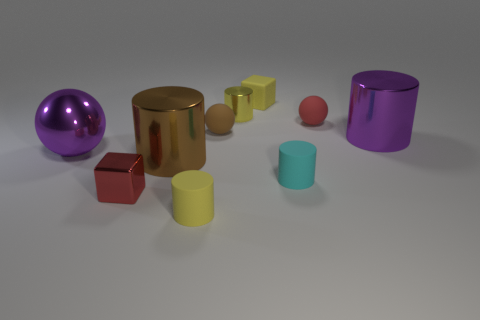What is the size of the metal cylinder that is the same color as the big ball?
Offer a terse response. Large. How many objects are either small balls that are right of the yellow cube or tiny matte things that are to the right of the small cyan matte thing?
Make the answer very short. 1. Is the shape of the yellow metal object the same as the small metal thing left of the brown cylinder?
Offer a terse response. No. How many other things are the same shape as the cyan object?
Provide a succinct answer. 4. How many things are big balls or purple things?
Your response must be concise. 2. Do the tiny rubber block and the big ball have the same color?
Ensure brevity in your answer.  No. There is a purple shiny object to the right of the rubber cylinder that is right of the yellow block; what shape is it?
Ensure brevity in your answer.  Cylinder. Are there fewer brown objects than large yellow matte blocks?
Ensure brevity in your answer.  No. There is a object that is both behind the small brown ball and in front of the tiny yellow shiny cylinder; what is its size?
Provide a succinct answer. Small. Does the brown rubber ball have the same size as the purple sphere?
Make the answer very short. No. 